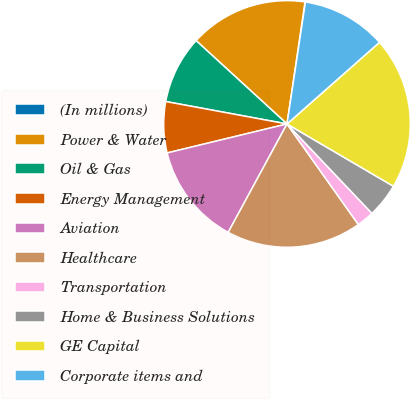Convert chart to OTSL. <chart><loc_0><loc_0><loc_500><loc_500><pie_chart><fcel>(In millions)<fcel>Power & Water<fcel>Oil & Gas<fcel>Energy Management<fcel>Aviation<fcel>Healthcare<fcel>Transportation<fcel>Home & Business Solutions<fcel>GE Capital<fcel>Corporate items and<nl><fcel>0.06%<fcel>15.52%<fcel>8.9%<fcel>6.69%<fcel>13.31%<fcel>17.73%<fcel>2.27%<fcel>4.48%<fcel>19.94%<fcel>11.1%<nl></chart> 